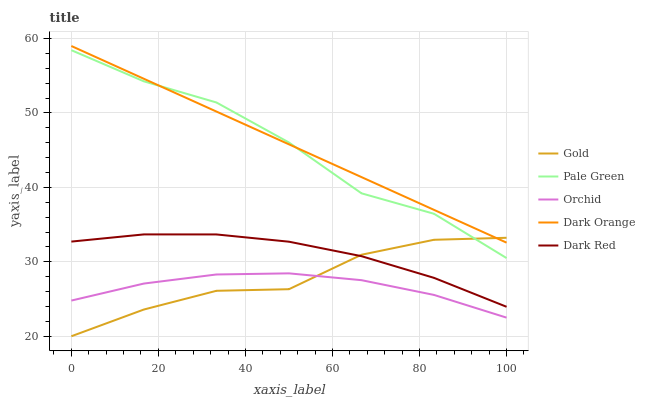Does Orchid have the minimum area under the curve?
Answer yes or no. Yes. Does Dark Orange have the maximum area under the curve?
Answer yes or no. Yes. Does Pale Green have the minimum area under the curve?
Answer yes or no. No. Does Pale Green have the maximum area under the curve?
Answer yes or no. No. Is Dark Orange the smoothest?
Answer yes or no. Yes. Is Pale Green the roughest?
Answer yes or no. Yes. Is Dark Red the smoothest?
Answer yes or no. No. Is Dark Red the roughest?
Answer yes or no. No. Does Gold have the lowest value?
Answer yes or no. Yes. Does Pale Green have the lowest value?
Answer yes or no. No. Does Dark Orange have the highest value?
Answer yes or no. Yes. Does Pale Green have the highest value?
Answer yes or no. No. Is Orchid less than Dark Red?
Answer yes or no. Yes. Is Dark Orange greater than Orchid?
Answer yes or no. Yes. Does Pale Green intersect Dark Orange?
Answer yes or no. Yes. Is Pale Green less than Dark Orange?
Answer yes or no. No. Is Pale Green greater than Dark Orange?
Answer yes or no. No. Does Orchid intersect Dark Red?
Answer yes or no. No. 